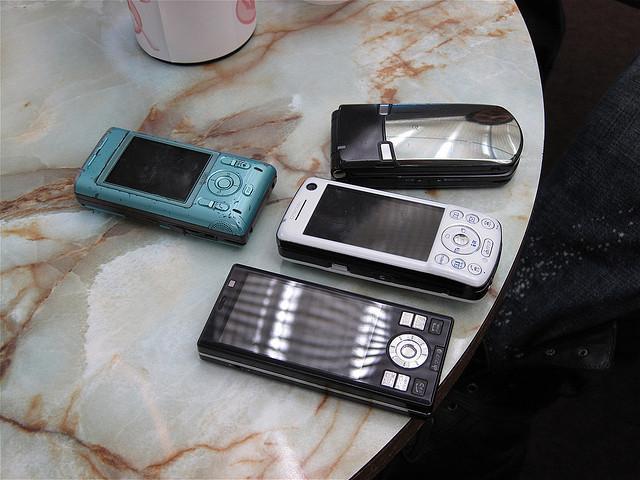How many cell phones can you see?
Give a very brief answer. 4. How many people are on the stairs?
Give a very brief answer. 0. 